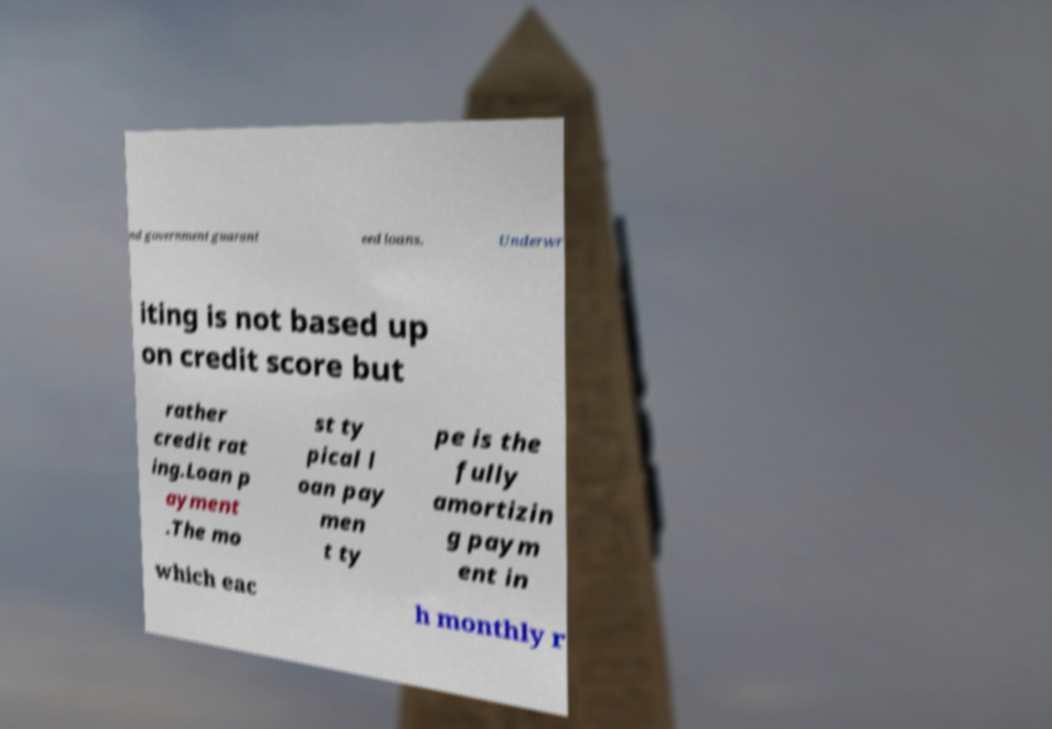Could you extract and type out the text from this image? nd government guarant eed loans. Underwr iting is not based up on credit score but rather credit rat ing.Loan p ayment .The mo st ty pical l oan pay men t ty pe is the fully amortizin g paym ent in which eac h monthly r 